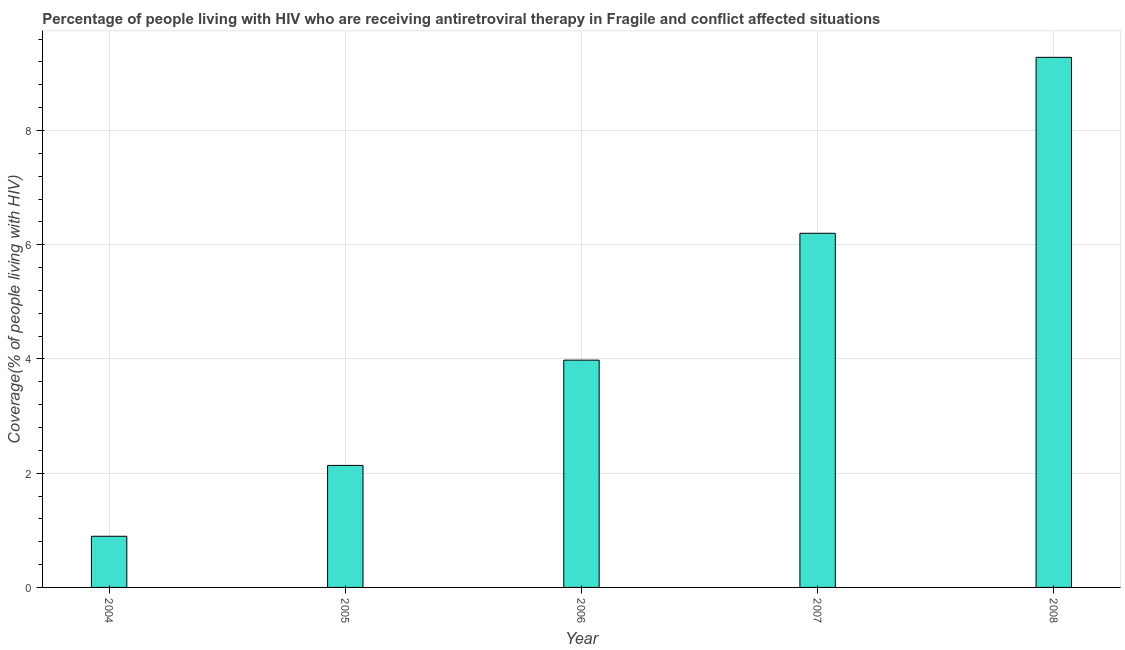What is the title of the graph?
Offer a very short reply. Percentage of people living with HIV who are receiving antiretroviral therapy in Fragile and conflict affected situations. What is the label or title of the Y-axis?
Provide a succinct answer. Coverage(% of people living with HIV). What is the antiretroviral therapy coverage in 2008?
Give a very brief answer. 9.28. Across all years, what is the maximum antiretroviral therapy coverage?
Offer a terse response. 9.28. Across all years, what is the minimum antiretroviral therapy coverage?
Give a very brief answer. 0.9. In which year was the antiretroviral therapy coverage maximum?
Give a very brief answer. 2008. What is the sum of the antiretroviral therapy coverage?
Make the answer very short. 22.49. What is the difference between the antiretroviral therapy coverage in 2006 and 2007?
Ensure brevity in your answer.  -2.22. What is the average antiretroviral therapy coverage per year?
Your answer should be very brief. 4.5. What is the median antiretroviral therapy coverage?
Provide a succinct answer. 3.98. What is the ratio of the antiretroviral therapy coverage in 2004 to that in 2007?
Offer a terse response. 0.14. Is the difference between the antiretroviral therapy coverage in 2005 and 2007 greater than the difference between any two years?
Provide a short and direct response. No. What is the difference between the highest and the second highest antiretroviral therapy coverage?
Make the answer very short. 3.08. What is the difference between the highest and the lowest antiretroviral therapy coverage?
Make the answer very short. 8.39. In how many years, is the antiretroviral therapy coverage greater than the average antiretroviral therapy coverage taken over all years?
Offer a terse response. 2. Are all the bars in the graph horizontal?
Provide a succinct answer. No. What is the difference between two consecutive major ticks on the Y-axis?
Offer a very short reply. 2. Are the values on the major ticks of Y-axis written in scientific E-notation?
Make the answer very short. No. What is the Coverage(% of people living with HIV) in 2004?
Keep it short and to the point. 0.9. What is the Coverage(% of people living with HIV) of 2005?
Give a very brief answer. 2.14. What is the Coverage(% of people living with HIV) in 2006?
Keep it short and to the point. 3.98. What is the Coverage(% of people living with HIV) in 2007?
Your response must be concise. 6.2. What is the Coverage(% of people living with HIV) of 2008?
Make the answer very short. 9.28. What is the difference between the Coverage(% of people living with HIV) in 2004 and 2005?
Offer a terse response. -1.24. What is the difference between the Coverage(% of people living with HIV) in 2004 and 2006?
Give a very brief answer. -3.08. What is the difference between the Coverage(% of people living with HIV) in 2004 and 2007?
Your answer should be very brief. -5.3. What is the difference between the Coverage(% of people living with HIV) in 2004 and 2008?
Ensure brevity in your answer.  -8.39. What is the difference between the Coverage(% of people living with HIV) in 2005 and 2006?
Make the answer very short. -1.84. What is the difference between the Coverage(% of people living with HIV) in 2005 and 2007?
Offer a very short reply. -4.06. What is the difference between the Coverage(% of people living with HIV) in 2005 and 2008?
Your response must be concise. -7.14. What is the difference between the Coverage(% of people living with HIV) in 2006 and 2007?
Give a very brief answer. -2.22. What is the difference between the Coverage(% of people living with HIV) in 2006 and 2008?
Your answer should be compact. -5.3. What is the difference between the Coverage(% of people living with HIV) in 2007 and 2008?
Your answer should be compact. -3.08. What is the ratio of the Coverage(% of people living with HIV) in 2004 to that in 2005?
Your answer should be very brief. 0.42. What is the ratio of the Coverage(% of people living with HIV) in 2004 to that in 2006?
Your answer should be compact. 0.23. What is the ratio of the Coverage(% of people living with HIV) in 2004 to that in 2007?
Provide a succinct answer. 0.14. What is the ratio of the Coverage(% of people living with HIV) in 2004 to that in 2008?
Keep it short and to the point. 0.1. What is the ratio of the Coverage(% of people living with HIV) in 2005 to that in 2006?
Offer a very short reply. 0.54. What is the ratio of the Coverage(% of people living with HIV) in 2005 to that in 2007?
Your answer should be compact. 0.34. What is the ratio of the Coverage(% of people living with HIV) in 2005 to that in 2008?
Offer a very short reply. 0.23. What is the ratio of the Coverage(% of people living with HIV) in 2006 to that in 2007?
Your answer should be compact. 0.64. What is the ratio of the Coverage(% of people living with HIV) in 2006 to that in 2008?
Your response must be concise. 0.43. What is the ratio of the Coverage(% of people living with HIV) in 2007 to that in 2008?
Provide a short and direct response. 0.67. 